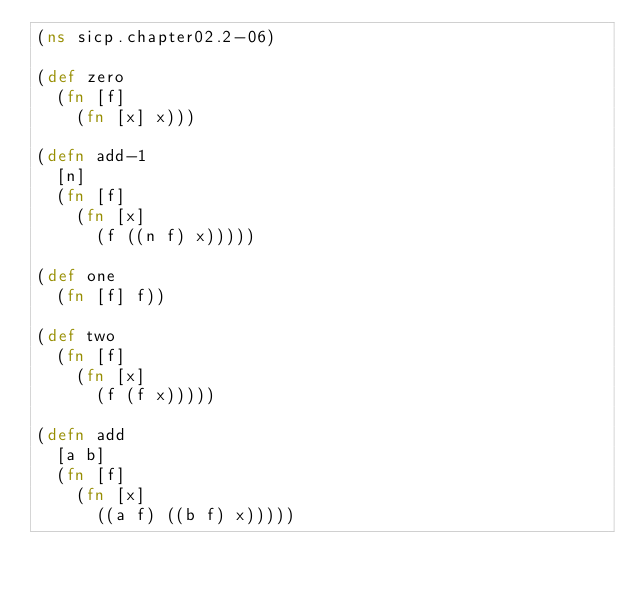<code> <loc_0><loc_0><loc_500><loc_500><_Clojure_>(ns sicp.chapter02.2-06)

(def zero
  (fn [f]
    (fn [x] x)))

(defn add-1
  [n]
  (fn [f]
    (fn [x]
      (f ((n f) x)))))

(def one
  (fn [f] f))

(def two
  (fn [f]
    (fn [x]
      (f (f x)))))

(defn add
  [a b]
  (fn [f]
    (fn [x]
      ((a f) ((b f) x)))))
</code> 